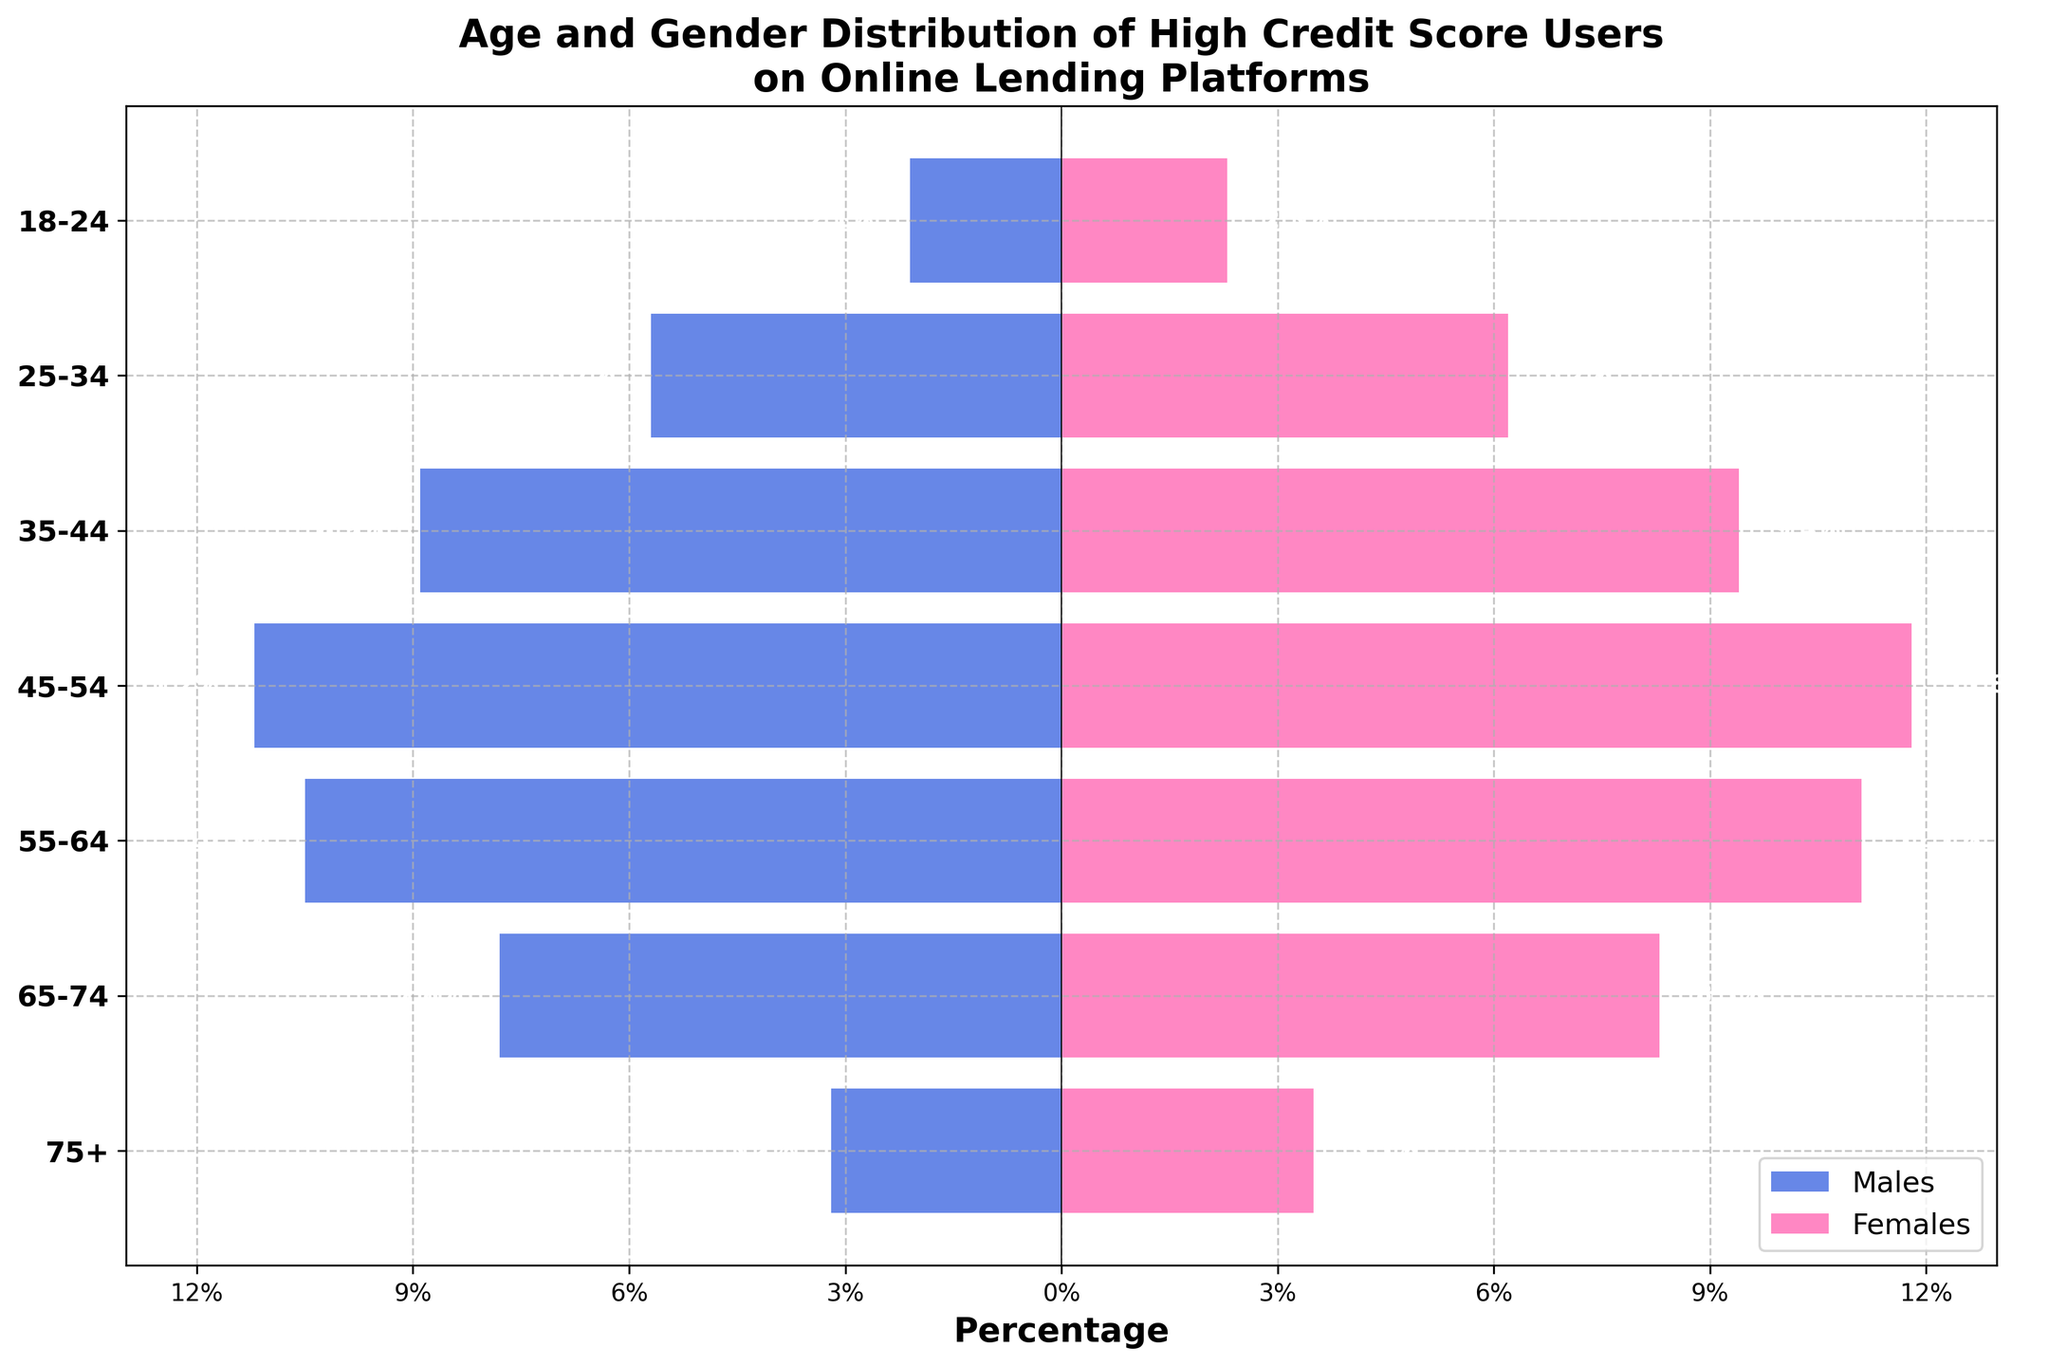What's the title of the figure? The title is typically placed at the top of the figure. In this case, it reads, "Age and Gender Distribution of High Credit Score Users on Online Lending Platforms." This title helps to understand what the figure represents.
Answer: Age and Gender Distribution of High Credit Score Users on Online Lending Platforms What's the percentage of males in the 35-44 age group? Look at the horizontal bar corresponding to the 35-44 age group. The figure associated with males in this group is approximately 8.9% as shown by the bar extending to the left and the label indicating the value.
Answer: 8.9% In which age group is there the largest percentage of females? Identify the age group that has the longest pink bar extending to the right. In this case, the 45-54 age group has the largest percentage of females, at 11.8%.
Answer: 45-54 How does the percentage of males and females compare in the 55-64 age group? Look at the bars for the 55-64 age group. Males have a bar extending to 10.5% on the left, while females have a bar extending to 11.1% on the right. Females have a slightly higher percentage.
Answer: Females are slightly higher What is the combined percentage of males and females aged 65-74 using online lending platforms? Sum the percentages of both genders in the 65-74 age group. Males represent 7.8% and females represent 8.3%. Adding these gives 7.8% + 8.3% = 16.1%.
Answer: 16.1% Which age group has a more balanced gender distribution? We look for the age group where the differences between the male and female bars are minimal. In the 18-24 age group, the difference is 2.3% - 2.1% = 0.2%, making it the most balanced.
Answer: 18-24 What is the difference in the percentage of males and females in the 75+ age group? Subtract the percentage of males from the percentage of females in the 75+ age group. This gives us 3.5% - 3.2% = 0.3%.
Answer: 0.3% Which gender has the highest represented age group and what is that percentage? Identify the highest point for each gender. The highest represented group for both genders is the 45-54 age group, with females at 11.8% and males at 11.2%. Females have the higher percentage.
Answer: Females, 11.8% How many age groups have more than 10% of their users in either gender? Go through each age group and identify if either the male or female bar exceeds 10%. The age groups that meet this criterion are the 45-54 (both) and 55-64 (both). That's two age groups in total.
Answer: Two age groups 